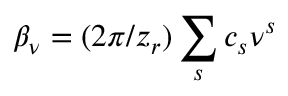Convert formula to latex. <formula><loc_0><loc_0><loc_500><loc_500>\beta _ { \nu } = ( 2 \pi / z _ { r } ) \sum _ { s } c _ { s } \nu ^ { s }</formula> 